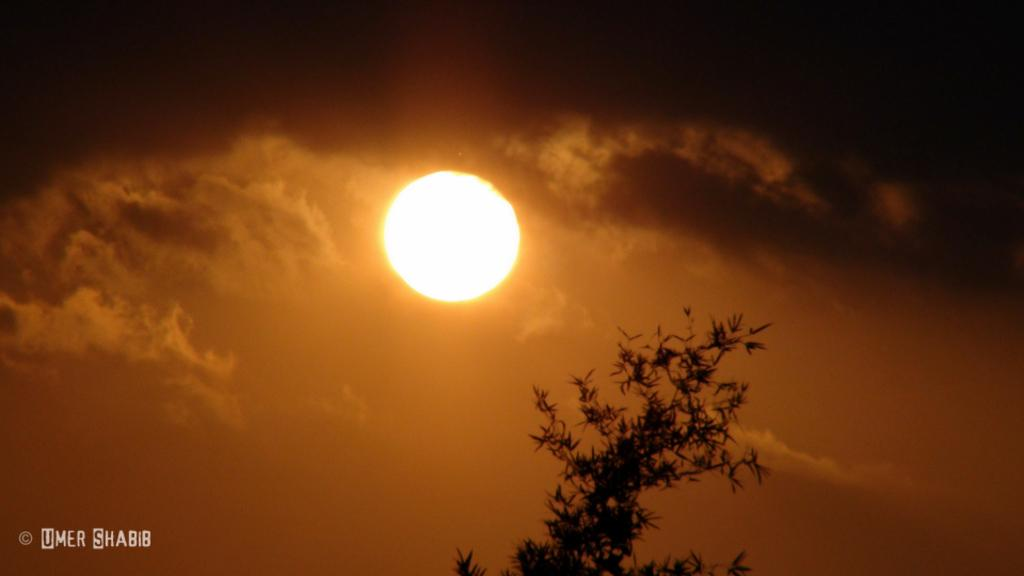What celestial body can be seen in the image? The sun is visible in the image. What else is present in the sky in the image? There are clouds in the image. What type of vegetation is present in the image? Leaves are present in the image. Can you describe any additional features of the image? There is a watermark in the image. How does the visitor feel about the rain in the image? There is no visitor or rain present in the image, so it is not possible to determine how a visitor might feel about the rain. 